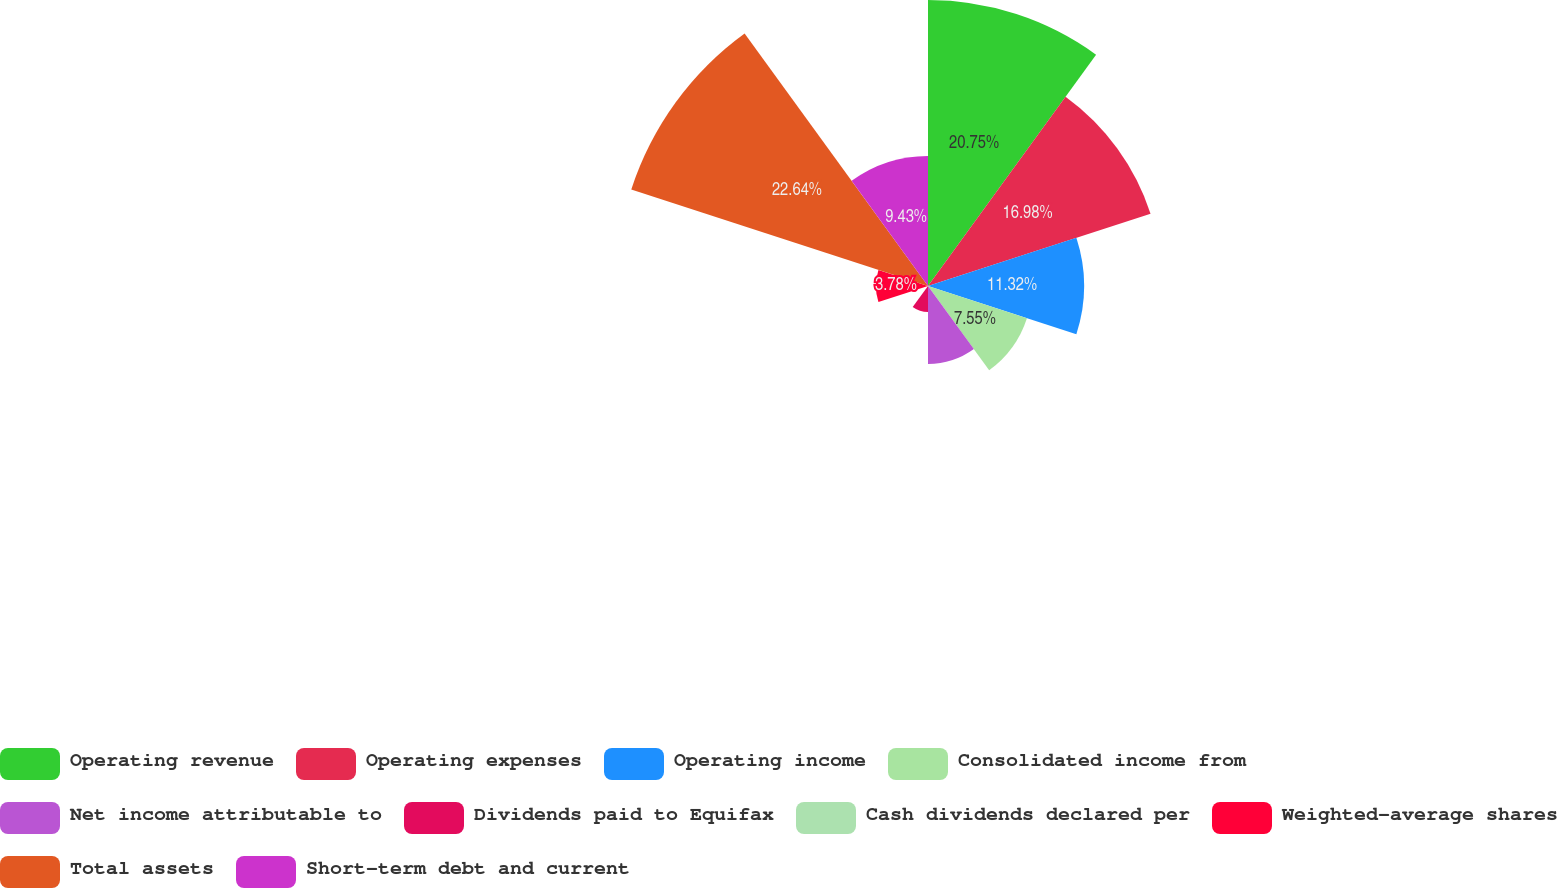Convert chart to OTSL. <chart><loc_0><loc_0><loc_500><loc_500><pie_chart><fcel>Operating revenue<fcel>Operating expenses<fcel>Operating income<fcel>Consolidated income from<fcel>Net income attributable to<fcel>Dividends paid to Equifax<fcel>Cash dividends declared per<fcel>Weighted-average shares<fcel>Total assets<fcel>Short-term debt and current<nl><fcel>20.75%<fcel>16.98%<fcel>11.32%<fcel>7.55%<fcel>5.66%<fcel>1.89%<fcel>0.0%<fcel>3.78%<fcel>22.64%<fcel>9.43%<nl></chart> 